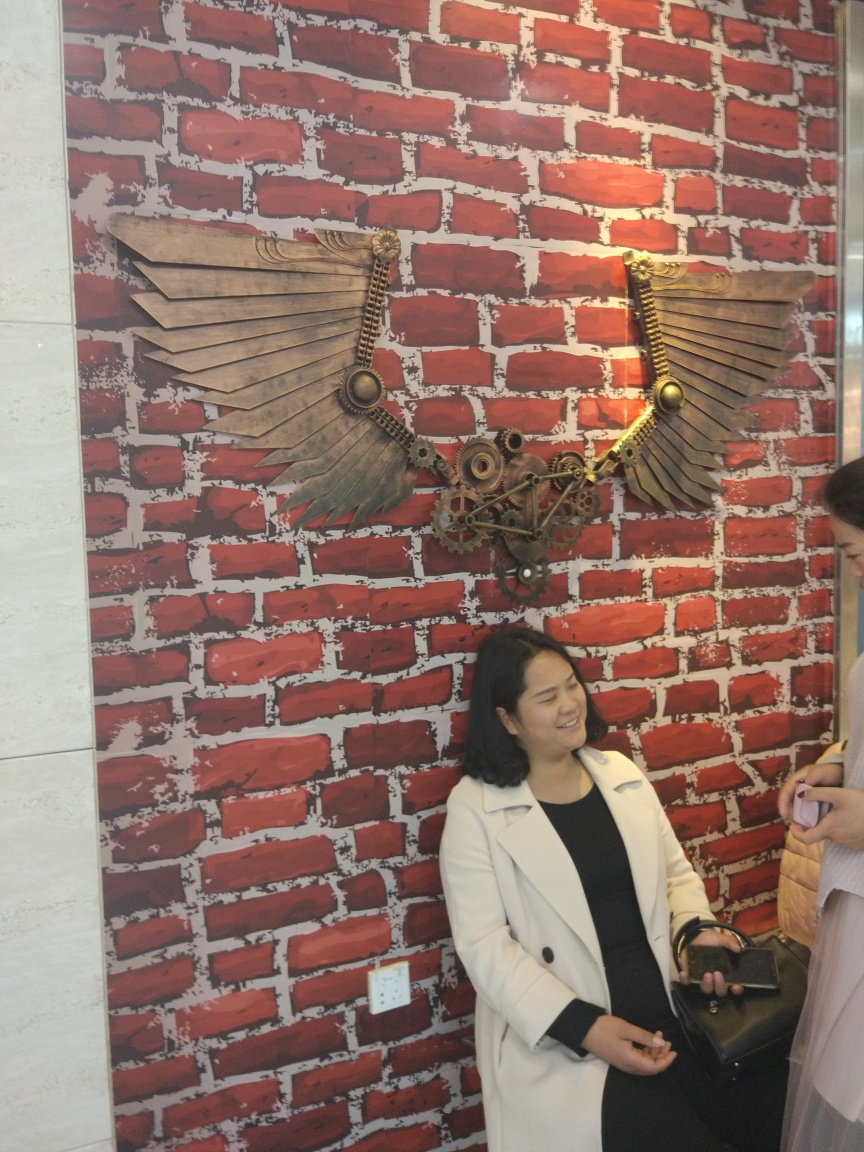What kind of place do you think the image is taken in? The image appears to be taken in a modern, possibly industrial-themed space, suggested by the mechanical wings on the brick wall. It could be a trendy cafe or a workspace that embraces a steampunk aesthetic.  Could you tell me more about the wings on the wall? Certainly! The wings are an artistic piece composed of wooden planks for feathers and mechanical gears, chains, and other elements for the main structure, creating a blend of natural and industrial motifs. It's a decorative element that could signify freedom or flight, creatively expressed through the steampunk genre. 